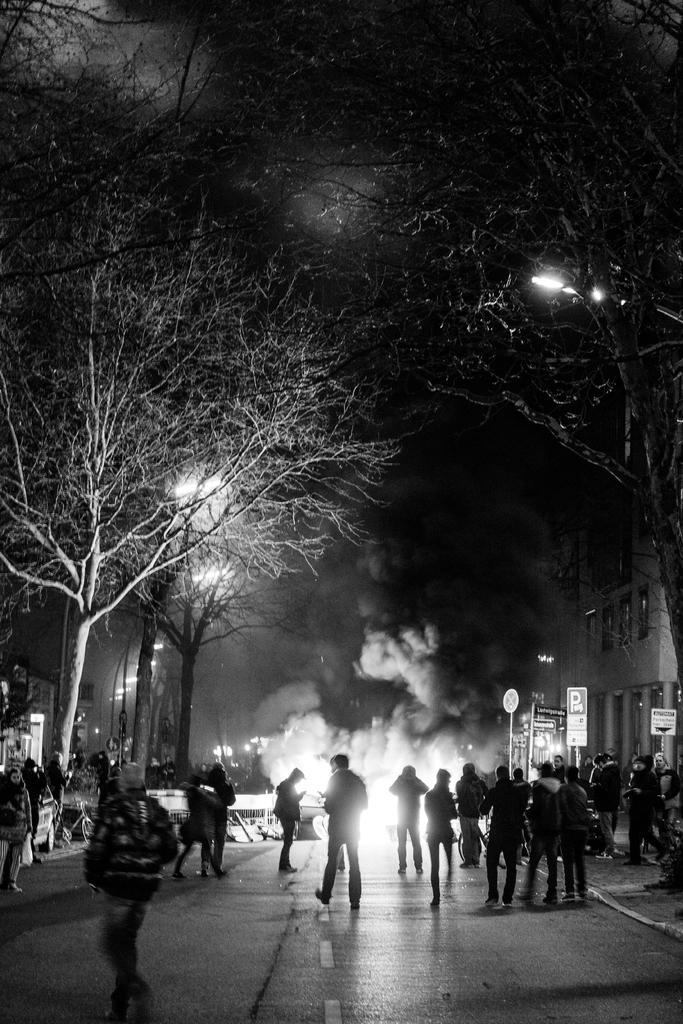What is happening on the road in the image? There are people on the road in the image. What type of natural elements can be seen in the image? There are trees in the image. What type of man-made structures are present in the image? There is at least one building in the image. What type of information might be conveyed by the sign boards in the image? The sign boards in the image might convey information about directions, warnings, or advertisements. What type of infrastructure is present in the image? There are light poles in the image. What type of transportation is visible in the image? There are vehicles in the image. What part of the natural environment is visible in the image? The sky is visible in the image. What type of disease is affecting the trees in the image? There is no indication of any disease affecting the trees in the image; they appear to be healthy. What type of sign is being held by the people in the image? There is no sign being held by the people in the image. 